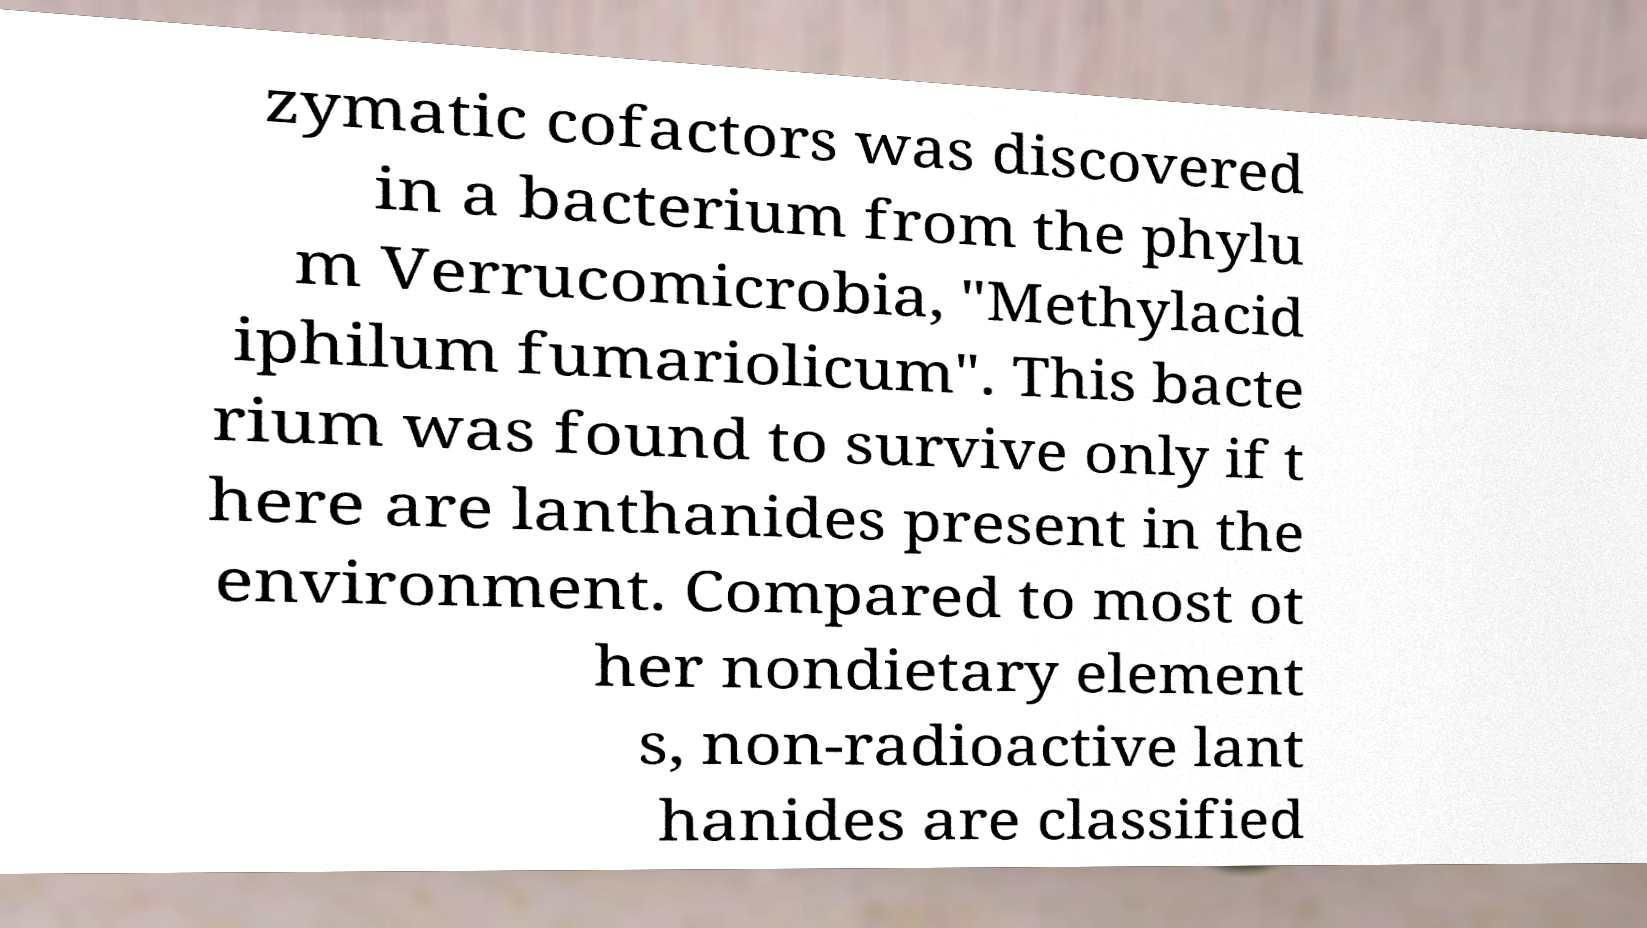Could you extract and type out the text from this image? zymatic cofactors was discovered in a bacterium from the phylu m Verrucomicrobia, "Methylacid iphilum fumariolicum". This bacte rium was found to survive only if t here are lanthanides present in the environment. Compared to most ot her nondietary element s, non-radioactive lant hanides are classified 